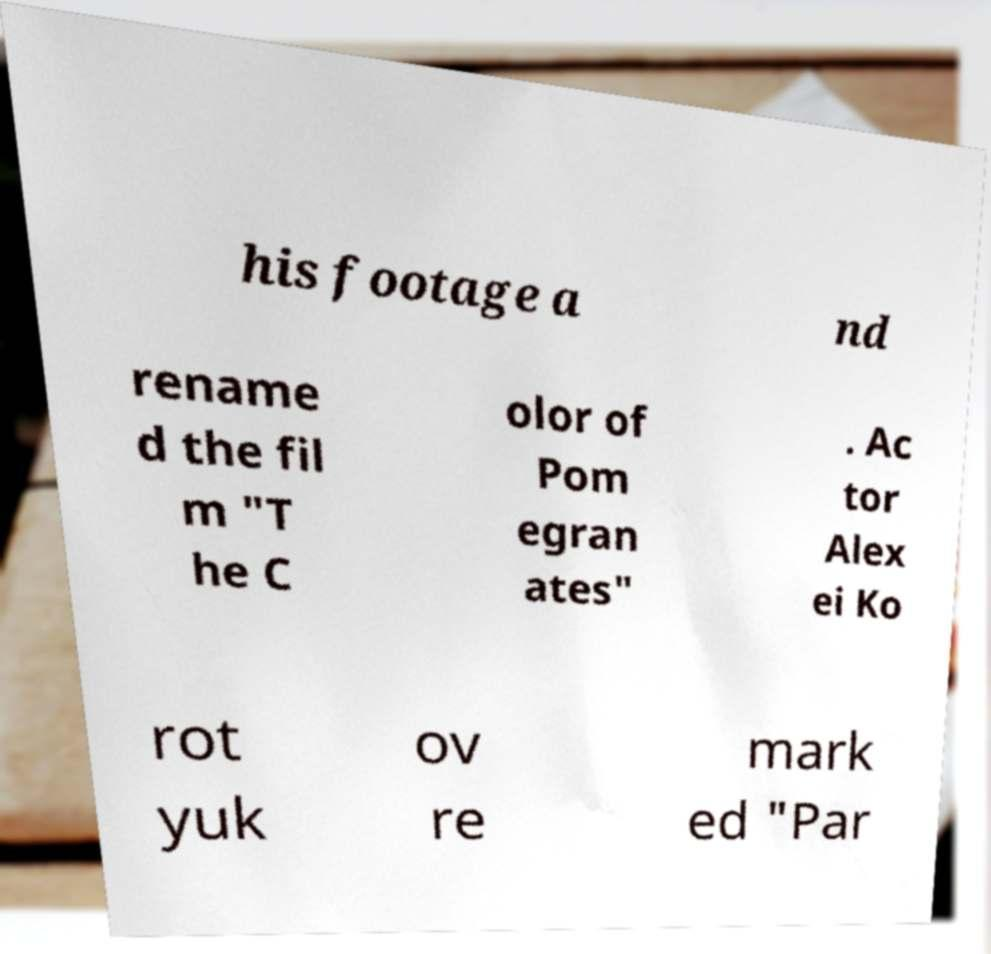What messages or text are displayed in this image? I need them in a readable, typed format. his footage a nd rename d the fil m "T he C olor of Pom egran ates" . Ac tor Alex ei Ko rot yuk ov re mark ed "Par 